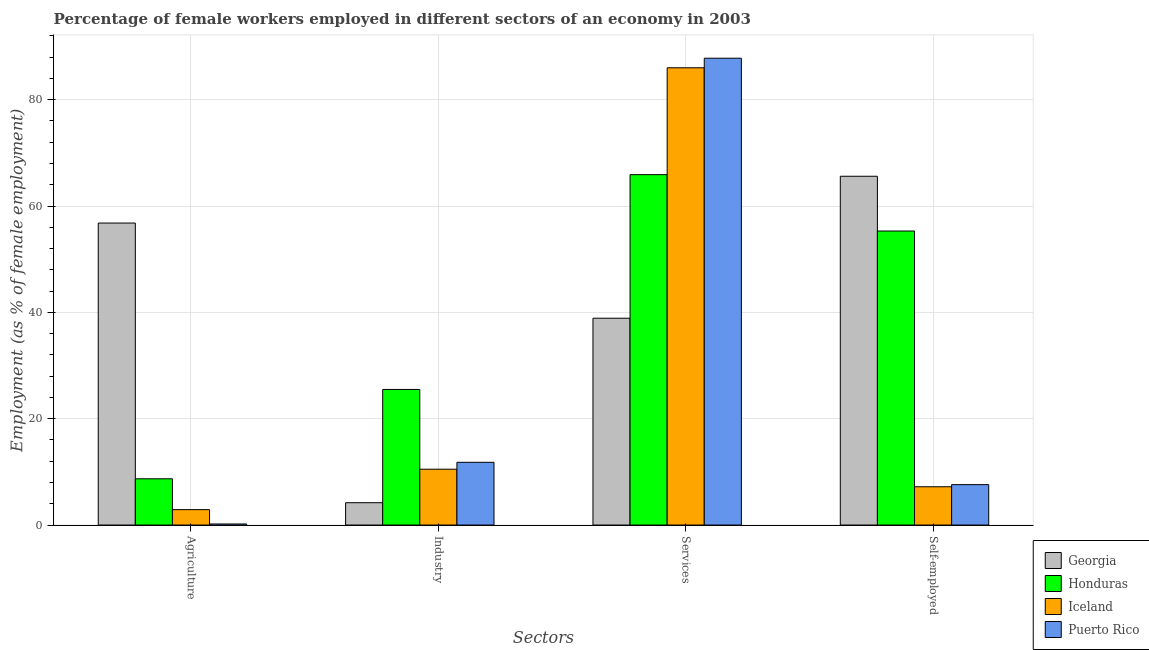How many different coloured bars are there?
Give a very brief answer. 4. Are the number of bars per tick equal to the number of legend labels?
Your answer should be compact. Yes. Are the number of bars on each tick of the X-axis equal?
Your answer should be compact. Yes. How many bars are there on the 4th tick from the left?
Keep it short and to the point. 4. How many bars are there on the 3rd tick from the right?
Make the answer very short. 4. What is the label of the 3rd group of bars from the left?
Your response must be concise. Services. What is the percentage of female workers in industry in Honduras?
Offer a terse response. 25.5. Across all countries, what is the maximum percentage of self employed female workers?
Provide a short and direct response. 65.6. Across all countries, what is the minimum percentage of female workers in services?
Provide a short and direct response. 38.9. In which country was the percentage of self employed female workers maximum?
Offer a very short reply. Georgia. What is the total percentage of female workers in services in the graph?
Make the answer very short. 278.6. What is the difference between the percentage of self employed female workers in Puerto Rico and that in Honduras?
Provide a short and direct response. -47.7. What is the difference between the percentage of self employed female workers in Georgia and the percentage of female workers in services in Iceland?
Offer a very short reply. -20.4. What is the average percentage of female workers in services per country?
Make the answer very short. 69.65. What is the difference between the percentage of female workers in industry and percentage of self employed female workers in Iceland?
Make the answer very short. 3.3. In how many countries, is the percentage of female workers in services greater than 44 %?
Ensure brevity in your answer.  3. What is the ratio of the percentage of self employed female workers in Georgia to that in Honduras?
Provide a succinct answer. 1.19. What is the difference between the highest and the second highest percentage of female workers in agriculture?
Your answer should be very brief. 48.1. What is the difference between the highest and the lowest percentage of self employed female workers?
Offer a terse response. 58.4. Is it the case that in every country, the sum of the percentage of female workers in industry and percentage of female workers in services is greater than the sum of percentage of self employed female workers and percentage of female workers in agriculture?
Offer a terse response. Yes. What does the 4th bar from the left in Industry represents?
Provide a short and direct response. Puerto Rico. What does the 1st bar from the right in Self-employed represents?
Offer a terse response. Puerto Rico. Are all the bars in the graph horizontal?
Give a very brief answer. No. How many countries are there in the graph?
Provide a succinct answer. 4. What is the difference between two consecutive major ticks on the Y-axis?
Offer a very short reply. 20. Are the values on the major ticks of Y-axis written in scientific E-notation?
Give a very brief answer. No. Does the graph contain any zero values?
Provide a short and direct response. No. Does the graph contain grids?
Provide a succinct answer. Yes. Where does the legend appear in the graph?
Make the answer very short. Bottom right. How are the legend labels stacked?
Ensure brevity in your answer.  Vertical. What is the title of the graph?
Give a very brief answer. Percentage of female workers employed in different sectors of an economy in 2003. Does "Philippines" appear as one of the legend labels in the graph?
Your answer should be very brief. No. What is the label or title of the X-axis?
Offer a very short reply. Sectors. What is the label or title of the Y-axis?
Give a very brief answer. Employment (as % of female employment). What is the Employment (as % of female employment) of Georgia in Agriculture?
Provide a short and direct response. 56.8. What is the Employment (as % of female employment) of Honduras in Agriculture?
Make the answer very short. 8.7. What is the Employment (as % of female employment) of Iceland in Agriculture?
Your response must be concise. 2.9. What is the Employment (as % of female employment) in Puerto Rico in Agriculture?
Provide a short and direct response. 0.2. What is the Employment (as % of female employment) in Georgia in Industry?
Your response must be concise. 4.2. What is the Employment (as % of female employment) in Honduras in Industry?
Your answer should be very brief. 25.5. What is the Employment (as % of female employment) in Puerto Rico in Industry?
Keep it short and to the point. 11.8. What is the Employment (as % of female employment) of Georgia in Services?
Keep it short and to the point. 38.9. What is the Employment (as % of female employment) in Honduras in Services?
Offer a terse response. 65.9. What is the Employment (as % of female employment) of Iceland in Services?
Provide a succinct answer. 86. What is the Employment (as % of female employment) in Puerto Rico in Services?
Give a very brief answer. 87.8. What is the Employment (as % of female employment) of Georgia in Self-employed?
Offer a terse response. 65.6. What is the Employment (as % of female employment) in Honduras in Self-employed?
Give a very brief answer. 55.3. What is the Employment (as % of female employment) of Iceland in Self-employed?
Your response must be concise. 7.2. What is the Employment (as % of female employment) of Puerto Rico in Self-employed?
Ensure brevity in your answer.  7.6. Across all Sectors, what is the maximum Employment (as % of female employment) in Georgia?
Provide a succinct answer. 65.6. Across all Sectors, what is the maximum Employment (as % of female employment) in Honduras?
Provide a short and direct response. 65.9. Across all Sectors, what is the maximum Employment (as % of female employment) in Puerto Rico?
Offer a terse response. 87.8. Across all Sectors, what is the minimum Employment (as % of female employment) of Georgia?
Provide a short and direct response. 4.2. Across all Sectors, what is the minimum Employment (as % of female employment) in Honduras?
Provide a short and direct response. 8.7. Across all Sectors, what is the minimum Employment (as % of female employment) of Iceland?
Your answer should be compact. 2.9. Across all Sectors, what is the minimum Employment (as % of female employment) in Puerto Rico?
Provide a short and direct response. 0.2. What is the total Employment (as % of female employment) of Georgia in the graph?
Keep it short and to the point. 165.5. What is the total Employment (as % of female employment) of Honduras in the graph?
Offer a terse response. 155.4. What is the total Employment (as % of female employment) of Iceland in the graph?
Offer a terse response. 106.6. What is the total Employment (as % of female employment) in Puerto Rico in the graph?
Keep it short and to the point. 107.4. What is the difference between the Employment (as % of female employment) in Georgia in Agriculture and that in Industry?
Give a very brief answer. 52.6. What is the difference between the Employment (as % of female employment) of Honduras in Agriculture and that in Industry?
Your answer should be very brief. -16.8. What is the difference between the Employment (as % of female employment) in Honduras in Agriculture and that in Services?
Offer a very short reply. -57.2. What is the difference between the Employment (as % of female employment) of Iceland in Agriculture and that in Services?
Make the answer very short. -83.1. What is the difference between the Employment (as % of female employment) of Puerto Rico in Agriculture and that in Services?
Keep it short and to the point. -87.6. What is the difference between the Employment (as % of female employment) of Honduras in Agriculture and that in Self-employed?
Provide a succinct answer. -46.6. What is the difference between the Employment (as % of female employment) of Georgia in Industry and that in Services?
Offer a very short reply. -34.7. What is the difference between the Employment (as % of female employment) of Honduras in Industry and that in Services?
Offer a terse response. -40.4. What is the difference between the Employment (as % of female employment) in Iceland in Industry and that in Services?
Your response must be concise. -75.5. What is the difference between the Employment (as % of female employment) of Puerto Rico in Industry and that in Services?
Provide a succinct answer. -76. What is the difference between the Employment (as % of female employment) of Georgia in Industry and that in Self-employed?
Provide a succinct answer. -61.4. What is the difference between the Employment (as % of female employment) in Honduras in Industry and that in Self-employed?
Your answer should be compact. -29.8. What is the difference between the Employment (as % of female employment) in Puerto Rico in Industry and that in Self-employed?
Your response must be concise. 4.2. What is the difference between the Employment (as % of female employment) in Georgia in Services and that in Self-employed?
Offer a terse response. -26.7. What is the difference between the Employment (as % of female employment) of Iceland in Services and that in Self-employed?
Give a very brief answer. 78.8. What is the difference between the Employment (as % of female employment) of Puerto Rico in Services and that in Self-employed?
Provide a succinct answer. 80.2. What is the difference between the Employment (as % of female employment) of Georgia in Agriculture and the Employment (as % of female employment) of Honduras in Industry?
Offer a very short reply. 31.3. What is the difference between the Employment (as % of female employment) of Georgia in Agriculture and the Employment (as % of female employment) of Iceland in Industry?
Give a very brief answer. 46.3. What is the difference between the Employment (as % of female employment) of Honduras in Agriculture and the Employment (as % of female employment) of Iceland in Industry?
Your answer should be very brief. -1.8. What is the difference between the Employment (as % of female employment) of Georgia in Agriculture and the Employment (as % of female employment) of Honduras in Services?
Give a very brief answer. -9.1. What is the difference between the Employment (as % of female employment) of Georgia in Agriculture and the Employment (as % of female employment) of Iceland in Services?
Offer a terse response. -29.2. What is the difference between the Employment (as % of female employment) in Georgia in Agriculture and the Employment (as % of female employment) in Puerto Rico in Services?
Keep it short and to the point. -31. What is the difference between the Employment (as % of female employment) in Honduras in Agriculture and the Employment (as % of female employment) in Iceland in Services?
Keep it short and to the point. -77.3. What is the difference between the Employment (as % of female employment) in Honduras in Agriculture and the Employment (as % of female employment) in Puerto Rico in Services?
Offer a very short reply. -79.1. What is the difference between the Employment (as % of female employment) in Iceland in Agriculture and the Employment (as % of female employment) in Puerto Rico in Services?
Give a very brief answer. -84.9. What is the difference between the Employment (as % of female employment) of Georgia in Agriculture and the Employment (as % of female employment) of Honduras in Self-employed?
Provide a succinct answer. 1.5. What is the difference between the Employment (as % of female employment) of Georgia in Agriculture and the Employment (as % of female employment) of Iceland in Self-employed?
Provide a short and direct response. 49.6. What is the difference between the Employment (as % of female employment) in Georgia in Agriculture and the Employment (as % of female employment) in Puerto Rico in Self-employed?
Your answer should be very brief. 49.2. What is the difference between the Employment (as % of female employment) of Honduras in Agriculture and the Employment (as % of female employment) of Iceland in Self-employed?
Offer a very short reply. 1.5. What is the difference between the Employment (as % of female employment) in Iceland in Agriculture and the Employment (as % of female employment) in Puerto Rico in Self-employed?
Your response must be concise. -4.7. What is the difference between the Employment (as % of female employment) of Georgia in Industry and the Employment (as % of female employment) of Honduras in Services?
Offer a very short reply. -61.7. What is the difference between the Employment (as % of female employment) of Georgia in Industry and the Employment (as % of female employment) of Iceland in Services?
Your answer should be very brief. -81.8. What is the difference between the Employment (as % of female employment) in Georgia in Industry and the Employment (as % of female employment) in Puerto Rico in Services?
Offer a very short reply. -83.6. What is the difference between the Employment (as % of female employment) of Honduras in Industry and the Employment (as % of female employment) of Iceland in Services?
Provide a short and direct response. -60.5. What is the difference between the Employment (as % of female employment) of Honduras in Industry and the Employment (as % of female employment) of Puerto Rico in Services?
Ensure brevity in your answer.  -62.3. What is the difference between the Employment (as % of female employment) of Iceland in Industry and the Employment (as % of female employment) of Puerto Rico in Services?
Your answer should be compact. -77.3. What is the difference between the Employment (as % of female employment) in Georgia in Industry and the Employment (as % of female employment) in Honduras in Self-employed?
Provide a short and direct response. -51.1. What is the difference between the Employment (as % of female employment) of Georgia in Industry and the Employment (as % of female employment) of Iceland in Self-employed?
Keep it short and to the point. -3. What is the difference between the Employment (as % of female employment) in Georgia in Industry and the Employment (as % of female employment) in Puerto Rico in Self-employed?
Provide a succinct answer. -3.4. What is the difference between the Employment (as % of female employment) in Honduras in Industry and the Employment (as % of female employment) in Iceland in Self-employed?
Your answer should be compact. 18.3. What is the difference between the Employment (as % of female employment) in Honduras in Industry and the Employment (as % of female employment) in Puerto Rico in Self-employed?
Provide a succinct answer. 17.9. What is the difference between the Employment (as % of female employment) in Georgia in Services and the Employment (as % of female employment) in Honduras in Self-employed?
Provide a short and direct response. -16.4. What is the difference between the Employment (as % of female employment) of Georgia in Services and the Employment (as % of female employment) of Iceland in Self-employed?
Give a very brief answer. 31.7. What is the difference between the Employment (as % of female employment) of Georgia in Services and the Employment (as % of female employment) of Puerto Rico in Self-employed?
Your answer should be compact. 31.3. What is the difference between the Employment (as % of female employment) of Honduras in Services and the Employment (as % of female employment) of Iceland in Self-employed?
Your response must be concise. 58.7. What is the difference between the Employment (as % of female employment) in Honduras in Services and the Employment (as % of female employment) in Puerto Rico in Self-employed?
Your response must be concise. 58.3. What is the difference between the Employment (as % of female employment) of Iceland in Services and the Employment (as % of female employment) of Puerto Rico in Self-employed?
Your answer should be compact. 78.4. What is the average Employment (as % of female employment) of Georgia per Sectors?
Your response must be concise. 41.38. What is the average Employment (as % of female employment) of Honduras per Sectors?
Give a very brief answer. 38.85. What is the average Employment (as % of female employment) in Iceland per Sectors?
Your answer should be very brief. 26.65. What is the average Employment (as % of female employment) in Puerto Rico per Sectors?
Provide a succinct answer. 26.85. What is the difference between the Employment (as % of female employment) in Georgia and Employment (as % of female employment) in Honduras in Agriculture?
Your answer should be very brief. 48.1. What is the difference between the Employment (as % of female employment) in Georgia and Employment (as % of female employment) in Iceland in Agriculture?
Keep it short and to the point. 53.9. What is the difference between the Employment (as % of female employment) in Georgia and Employment (as % of female employment) in Puerto Rico in Agriculture?
Provide a short and direct response. 56.6. What is the difference between the Employment (as % of female employment) in Iceland and Employment (as % of female employment) in Puerto Rico in Agriculture?
Provide a succinct answer. 2.7. What is the difference between the Employment (as % of female employment) in Georgia and Employment (as % of female employment) in Honduras in Industry?
Make the answer very short. -21.3. What is the difference between the Employment (as % of female employment) of Georgia and Employment (as % of female employment) of Iceland in Industry?
Keep it short and to the point. -6.3. What is the difference between the Employment (as % of female employment) in Georgia and Employment (as % of female employment) in Puerto Rico in Industry?
Keep it short and to the point. -7.6. What is the difference between the Employment (as % of female employment) of Georgia and Employment (as % of female employment) of Honduras in Services?
Give a very brief answer. -27. What is the difference between the Employment (as % of female employment) of Georgia and Employment (as % of female employment) of Iceland in Services?
Make the answer very short. -47.1. What is the difference between the Employment (as % of female employment) of Georgia and Employment (as % of female employment) of Puerto Rico in Services?
Give a very brief answer. -48.9. What is the difference between the Employment (as % of female employment) of Honduras and Employment (as % of female employment) of Iceland in Services?
Keep it short and to the point. -20.1. What is the difference between the Employment (as % of female employment) in Honduras and Employment (as % of female employment) in Puerto Rico in Services?
Keep it short and to the point. -21.9. What is the difference between the Employment (as % of female employment) of Iceland and Employment (as % of female employment) of Puerto Rico in Services?
Make the answer very short. -1.8. What is the difference between the Employment (as % of female employment) of Georgia and Employment (as % of female employment) of Iceland in Self-employed?
Your answer should be compact. 58.4. What is the difference between the Employment (as % of female employment) in Georgia and Employment (as % of female employment) in Puerto Rico in Self-employed?
Provide a short and direct response. 58. What is the difference between the Employment (as % of female employment) in Honduras and Employment (as % of female employment) in Iceland in Self-employed?
Provide a succinct answer. 48.1. What is the difference between the Employment (as % of female employment) of Honduras and Employment (as % of female employment) of Puerto Rico in Self-employed?
Offer a terse response. 47.7. What is the difference between the Employment (as % of female employment) in Iceland and Employment (as % of female employment) in Puerto Rico in Self-employed?
Provide a succinct answer. -0.4. What is the ratio of the Employment (as % of female employment) of Georgia in Agriculture to that in Industry?
Make the answer very short. 13.52. What is the ratio of the Employment (as % of female employment) of Honduras in Agriculture to that in Industry?
Offer a very short reply. 0.34. What is the ratio of the Employment (as % of female employment) in Iceland in Agriculture to that in Industry?
Provide a succinct answer. 0.28. What is the ratio of the Employment (as % of female employment) of Puerto Rico in Agriculture to that in Industry?
Give a very brief answer. 0.02. What is the ratio of the Employment (as % of female employment) in Georgia in Agriculture to that in Services?
Ensure brevity in your answer.  1.46. What is the ratio of the Employment (as % of female employment) of Honduras in Agriculture to that in Services?
Offer a very short reply. 0.13. What is the ratio of the Employment (as % of female employment) in Iceland in Agriculture to that in Services?
Ensure brevity in your answer.  0.03. What is the ratio of the Employment (as % of female employment) in Puerto Rico in Agriculture to that in Services?
Provide a short and direct response. 0. What is the ratio of the Employment (as % of female employment) of Georgia in Agriculture to that in Self-employed?
Give a very brief answer. 0.87. What is the ratio of the Employment (as % of female employment) in Honduras in Agriculture to that in Self-employed?
Offer a very short reply. 0.16. What is the ratio of the Employment (as % of female employment) of Iceland in Agriculture to that in Self-employed?
Your response must be concise. 0.4. What is the ratio of the Employment (as % of female employment) of Puerto Rico in Agriculture to that in Self-employed?
Offer a very short reply. 0.03. What is the ratio of the Employment (as % of female employment) in Georgia in Industry to that in Services?
Your response must be concise. 0.11. What is the ratio of the Employment (as % of female employment) of Honduras in Industry to that in Services?
Give a very brief answer. 0.39. What is the ratio of the Employment (as % of female employment) in Iceland in Industry to that in Services?
Make the answer very short. 0.12. What is the ratio of the Employment (as % of female employment) in Puerto Rico in Industry to that in Services?
Provide a succinct answer. 0.13. What is the ratio of the Employment (as % of female employment) of Georgia in Industry to that in Self-employed?
Make the answer very short. 0.06. What is the ratio of the Employment (as % of female employment) of Honduras in Industry to that in Self-employed?
Keep it short and to the point. 0.46. What is the ratio of the Employment (as % of female employment) of Iceland in Industry to that in Self-employed?
Give a very brief answer. 1.46. What is the ratio of the Employment (as % of female employment) in Puerto Rico in Industry to that in Self-employed?
Offer a terse response. 1.55. What is the ratio of the Employment (as % of female employment) in Georgia in Services to that in Self-employed?
Offer a very short reply. 0.59. What is the ratio of the Employment (as % of female employment) of Honduras in Services to that in Self-employed?
Your response must be concise. 1.19. What is the ratio of the Employment (as % of female employment) in Iceland in Services to that in Self-employed?
Make the answer very short. 11.94. What is the ratio of the Employment (as % of female employment) in Puerto Rico in Services to that in Self-employed?
Make the answer very short. 11.55. What is the difference between the highest and the second highest Employment (as % of female employment) in Georgia?
Make the answer very short. 8.8. What is the difference between the highest and the second highest Employment (as % of female employment) in Iceland?
Your answer should be compact. 75.5. What is the difference between the highest and the lowest Employment (as % of female employment) in Georgia?
Provide a succinct answer. 61.4. What is the difference between the highest and the lowest Employment (as % of female employment) in Honduras?
Your answer should be compact. 57.2. What is the difference between the highest and the lowest Employment (as % of female employment) in Iceland?
Offer a very short reply. 83.1. What is the difference between the highest and the lowest Employment (as % of female employment) in Puerto Rico?
Ensure brevity in your answer.  87.6. 